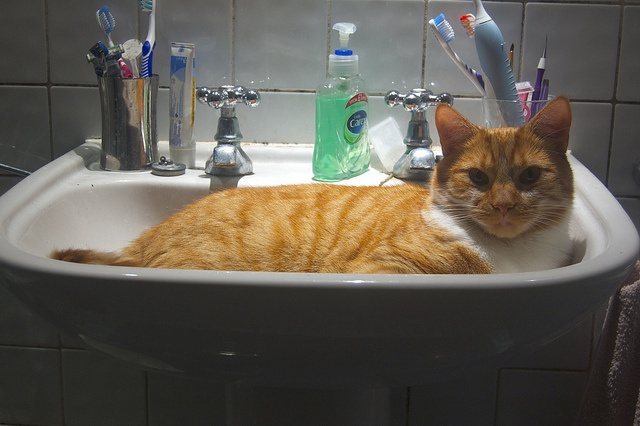Describe the objects in this image and their specific colors. I can see cat in black, tan, maroon, and olive tones, sink in black, darkgray, lightgray, and gray tones, bottle in black, turquoise, darkgray, green, and lightgreen tones, cup in black and gray tones, and toothbrush in black, gray, and darkgray tones in this image. 